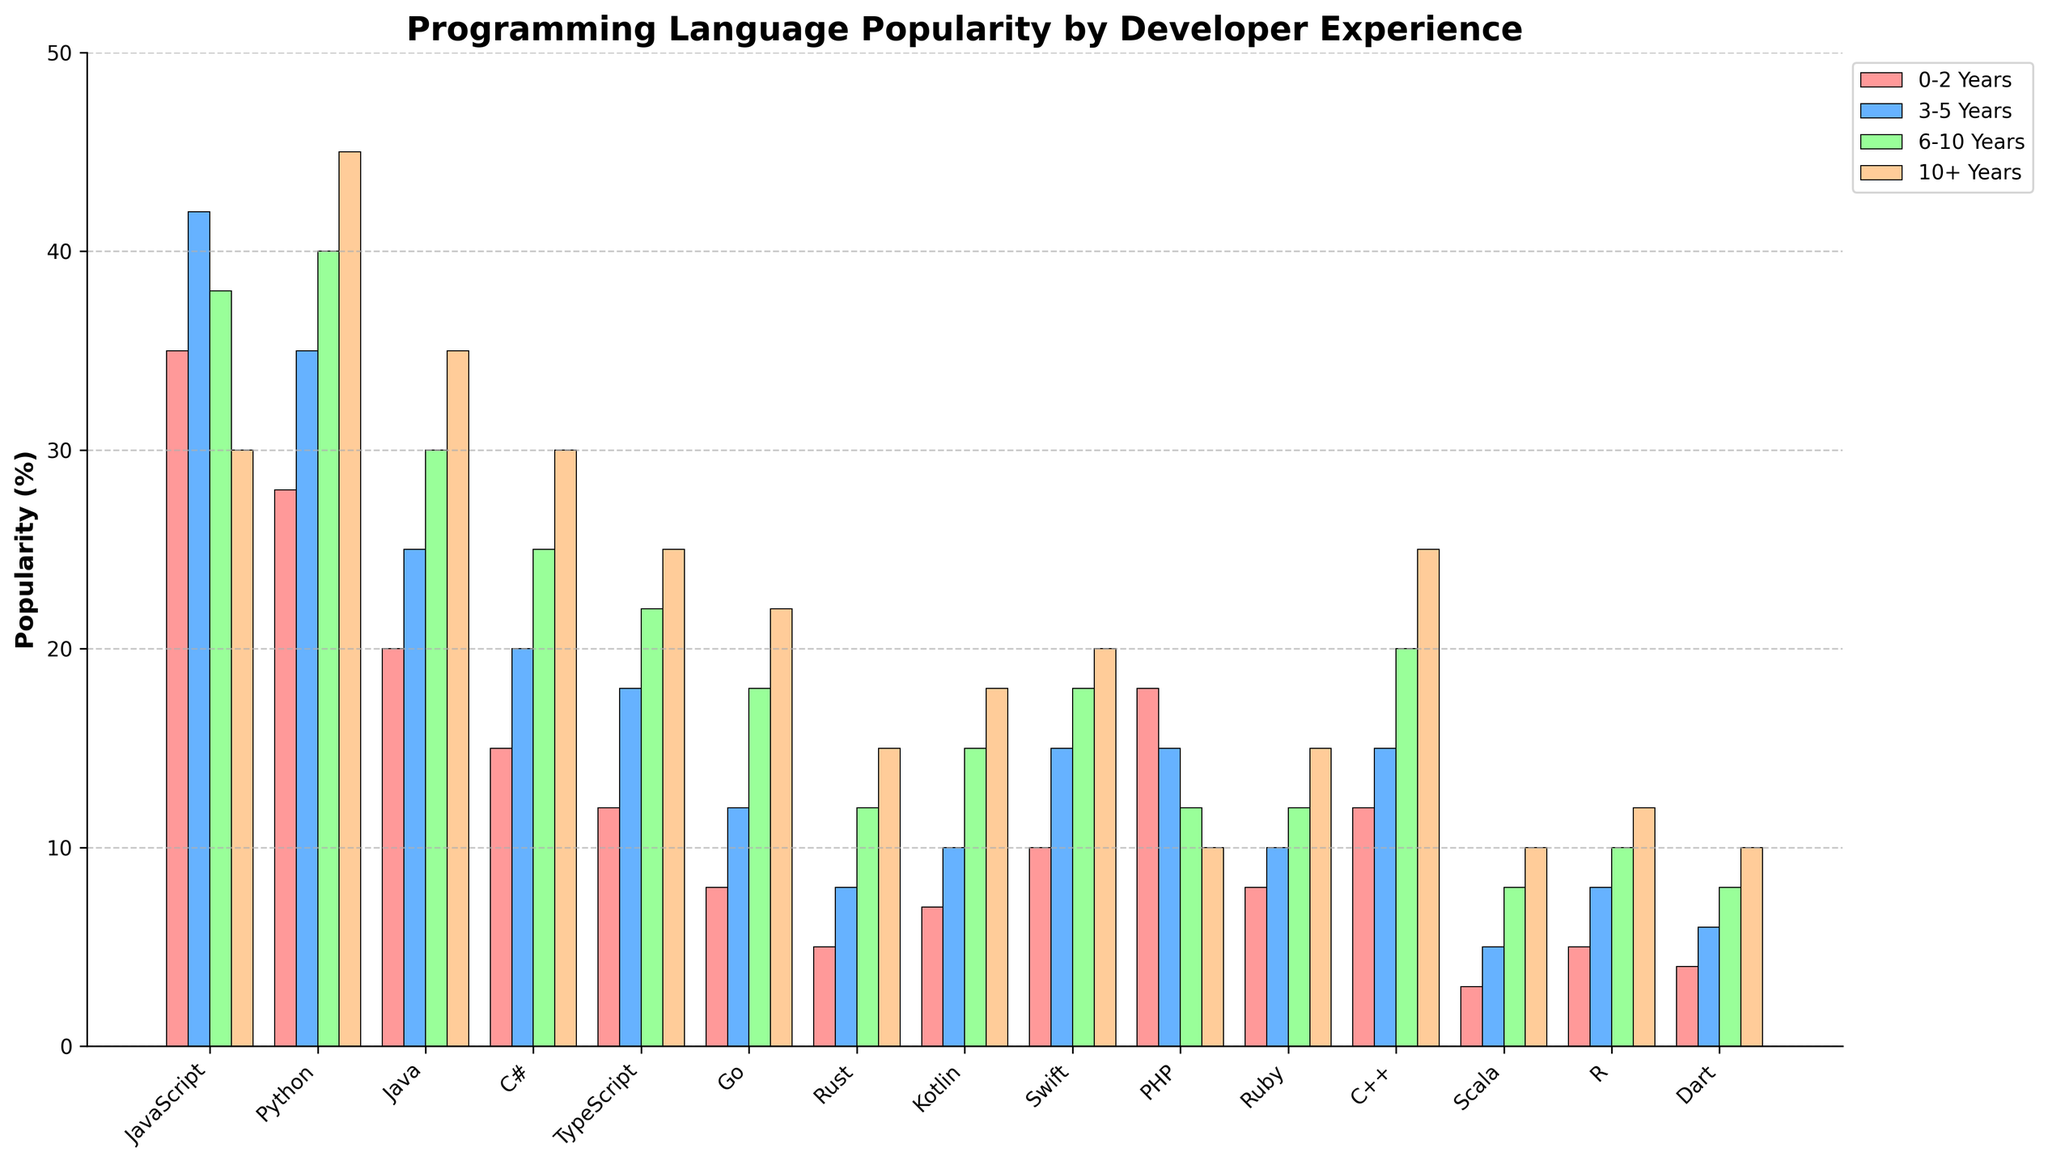What is the most popular programming language among developers with 6-10 years of experience? To find the most popular language for developers with 6-10 years of experience, look at the bar heights corresponding to the "6-10 Years" experience category. The highest bar in this group represents the most popular language. Python has the highest bar in this category.
Answer: Python Which language has a higher popularity among developers with 0-2 years of experience: Java or C#? Compare the bars for Java and C# in the "0-2 Years" category. Java has a bar height of 20%, while C# has a bar height of 15%.
Answer: Java By how much does the popularity of TypeScript increase from the 0-2 years category to the 10+ years category? Look at the bar heights for TypeScript in both categories. For 0-2 years, TypeScript has a height of 12%, and for 10+ years, it's 25%. The increase is 25% - 12% = 13%.
Answer: 13% What are the top two most popular languages among developers with 10+ years of experience? To find the top two languages for the 10+ years category, identify the two tallest bars in this section. Python and JavaScript are the tallest with bar heights of 45% and 30% respectively.
Answer: Python, JavaScript Which language shows a decrease in popularity as the experience level increases? To find a language that decreases in popularity with more experience, trace the bar heights across increasing experience levels. PHP shows a decrease from 18% in 0-2 years to 10% in 10+ years.
Answer: PHP How much more popular is Rust among developers with 10+ years of experience compared to those with 0-2 years of experience? Check the bar heights for Rust in these categories. For 0-2 years, it’s 5%, and for 10+ years, it’s 15%. The difference is 15% - 5% = 10%.
Answer: 10% What is the average popularity of C++ across all experience levels? To find the average, add up the bar heights for C++ in all experience categories and divide by 4. The values are 12%, 15%, 20%, and 25%, resulting in (12 + 15 + 20 + 25) / 4 = 72 / 4 = 18%.
Answer: 18% Which experience level has the highest overall count of languages with a popularity above 20%? Count the number of bars above 20% for each experience level. For the 0-2 years category, there is one (JavaScript). For 3-5 years, there is one (JavaScript). For 6-10 years, there are two (JavaScript, Python). For 10+ years, there are three (Python, Java, C#). The 10+ years category has the highest count.
Answer: 10+ years 